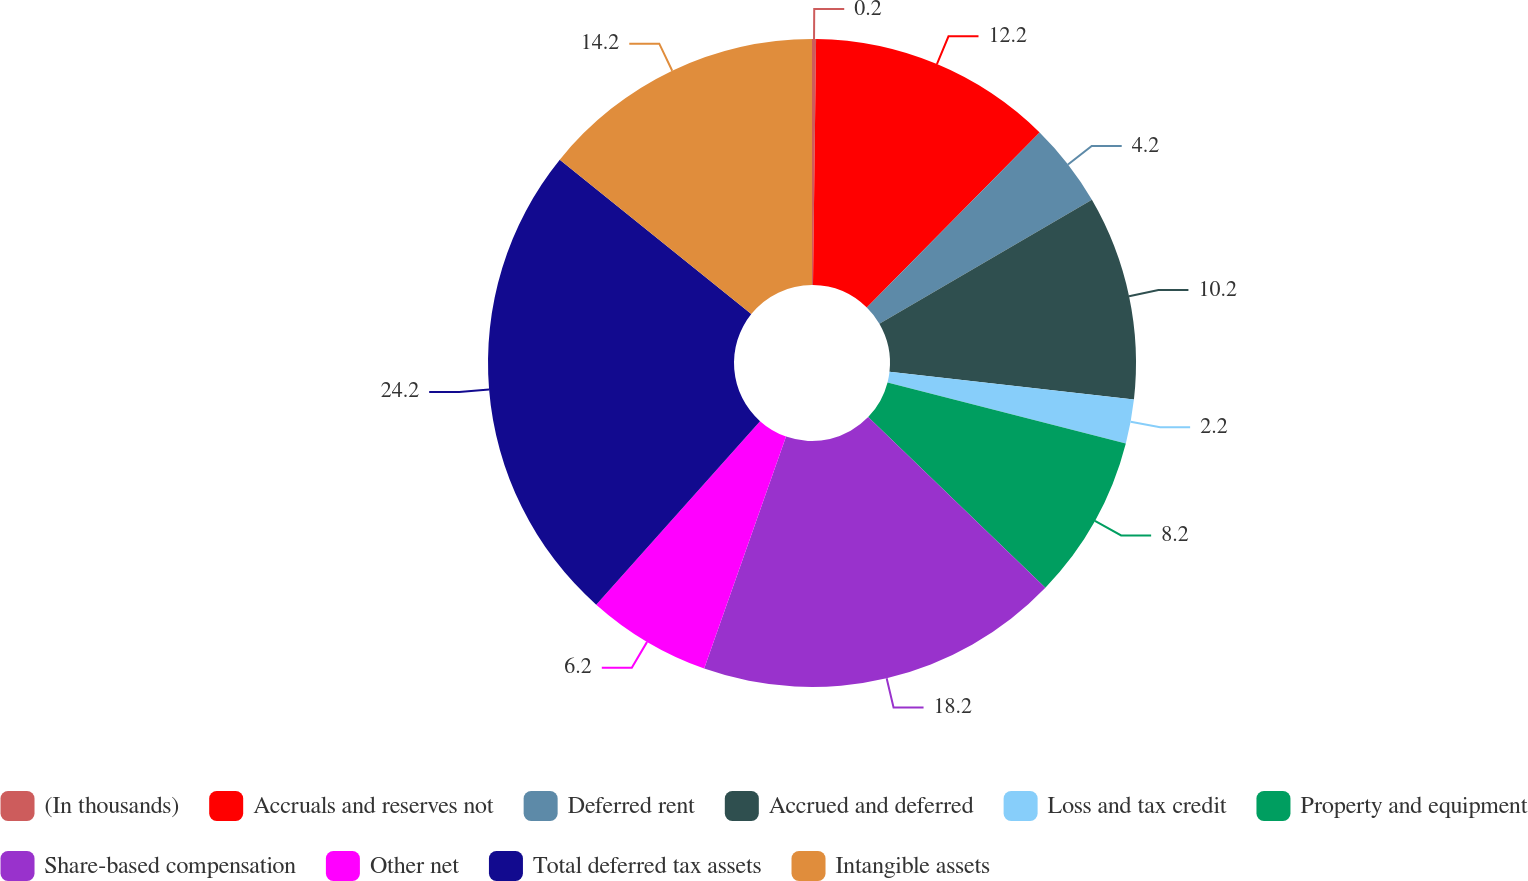Convert chart. <chart><loc_0><loc_0><loc_500><loc_500><pie_chart><fcel>(In thousands)<fcel>Accruals and reserves not<fcel>Deferred rent<fcel>Accrued and deferred<fcel>Loss and tax credit<fcel>Property and equipment<fcel>Share-based compensation<fcel>Other net<fcel>Total deferred tax assets<fcel>Intangible assets<nl><fcel>0.2%<fcel>12.2%<fcel>4.2%<fcel>10.2%<fcel>2.2%<fcel>8.2%<fcel>18.2%<fcel>6.2%<fcel>24.2%<fcel>14.2%<nl></chart> 